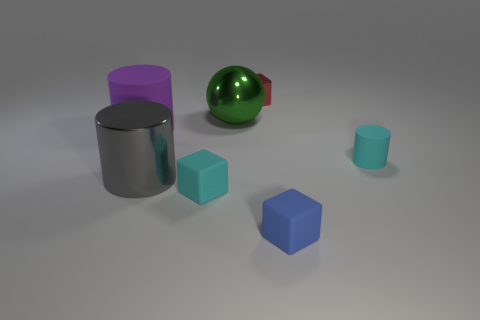There is a small rubber thing on the left side of the small red metal object; what color is it?
Provide a short and direct response. Cyan. What is the shape of the red metal thing?
Offer a terse response. Cube. What is the material of the block that is behind the small rubber object left of the small red shiny cube?
Your answer should be very brief. Metal. What number of other objects are there of the same material as the red object?
Make the answer very short. 2. There is a cyan block that is the same size as the red thing; what is it made of?
Your response must be concise. Rubber. Is the number of tiny blue blocks that are to the left of the red block greater than the number of tiny red metallic things on the left side of the large green shiny thing?
Your answer should be compact. No. Is there a blue object that has the same shape as the large gray shiny object?
Your answer should be compact. No. What is the shape of the red metallic thing that is the same size as the blue rubber cube?
Provide a short and direct response. Cube. There is a cyan object behind the gray cylinder; what shape is it?
Your answer should be compact. Cylinder. Are there fewer purple rubber objects that are on the right side of the tiny cyan rubber cube than small matte objects to the right of the blue object?
Offer a very short reply. Yes. 